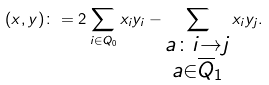<formula> <loc_0><loc_0><loc_500><loc_500>( x , y ) \colon = 2 \sum _ { i \in Q _ { 0 } } x _ { i } y _ { i } - \sum _ { \substack { a \colon i \rightarrow j \\ a \in \overline { Q } _ { 1 } } } x _ { i } y _ { j } .</formula> 